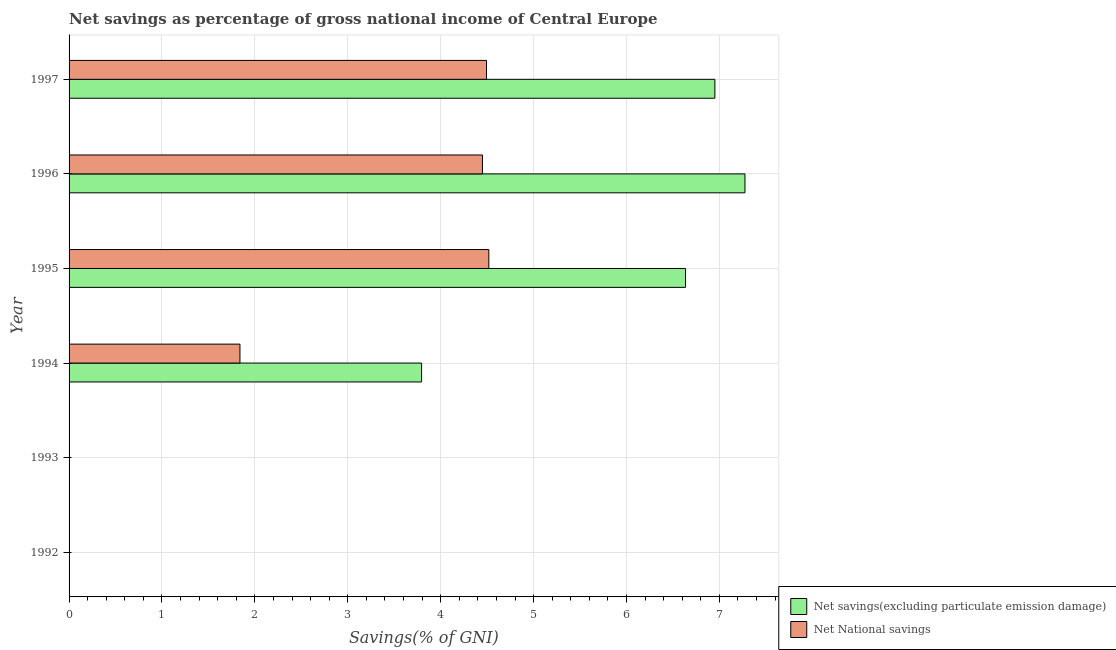How many different coloured bars are there?
Your response must be concise. 2. Are the number of bars on each tick of the Y-axis equal?
Provide a succinct answer. No. What is the label of the 5th group of bars from the top?
Provide a succinct answer. 1993. What is the net savings(excluding particulate emission damage) in 1993?
Ensure brevity in your answer.  0. Across all years, what is the maximum net national savings?
Provide a succinct answer. 4.52. Across all years, what is the minimum net national savings?
Provide a short and direct response. 0. What is the total net savings(excluding particulate emission damage) in the graph?
Offer a very short reply. 24.66. What is the difference between the net savings(excluding particulate emission damage) in 1994 and that in 1996?
Offer a terse response. -3.48. What is the difference between the net savings(excluding particulate emission damage) in 1997 and the net national savings in 1995?
Ensure brevity in your answer.  2.43. What is the average net national savings per year?
Give a very brief answer. 2.55. In the year 1995, what is the difference between the net savings(excluding particulate emission damage) and net national savings?
Offer a terse response. 2.12. In how many years, is the net national savings greater than 3.6 %?
Offer a very short reply. 3. What is the ratio of the net savings(excluding particulate emission damage) in 1995 to that in 1997?
Your answer should be very brief. 0.95. Is the net savings(excluding particulate emission damage) in 1996 less than that in 1997?
Ensure brevity in your answer.  No. Is the difference between the net savings(excluding particulate emission damage) in 1995 and 1997 greater than the difference between the net national savings in 1995 and 1997?
Give a very brief answer. No. What is the difference between the highest and the second highest net national savings?
Ensure brevity in your answer.  0.03. What is the difference between the highest and the lowest net savings(excluding particulate emission damage)?
Make the answer very short. 7.28. In how many years, is the net national savings greater than the average net national savings taken over all years?
Your answer should be very brief. 3. How many bars are there?
Your answer should be very brief. 8. Does the graph contain any zero values?
Keep it short and to the point. Yes. What is the title of the graph?
Provide a short and direct response. Net savings as percentage of gross national income of Central Europe. What is the label or title of the X-axis?
Make the answer very short. Savings(% of GNI). What is the label or title of the Y-axis?
Give a very brief answer. Year. What is the Savings(% of GNI) in Net savings(excluding particulate emission damage) in 1992?
Offer a very short reply. 0. What is the Savings(% of GNI) of Net savings(excluding particulate emission damage) in 1993?
Make the answer very short. 0. What is the Savings(% of GNI) of Net savings(excluding particulate emission damage) in 1994?
Your answer should be compact. 3.79. What is the Savings(% of GNI) of Net National savings in 1994?
Your response must be concise. 1.84. What is the Savings(% of GNI) in Net savings(excluding particulate emission damage) in 1995?
Your answer should be very brief. 6.64. What is the Savings(% of GNI) in Net National savings in 1995?
Your answer should be compact. 4.52. What is the Savings(% of GNI) of Net savings(excluding particulate emission damage) in 1996?
Provide a succinct answer. 7.28. What is the Savings(% of GNI) in Net National savings in 1996?
Provide a succinct answer. 4.45. What is the Savings(% of GNI) in Net savings(excluding particulate emission damage) in 1997?
Keep it short and to the point. 6.95. What is the Savings(% of GNI) in Net National savings in 1997?
Make the answer very short. 4.49. Across all years, what is the maximum Savings(% of GNI) in Net savings(excluding particulate emission damage)?
Make the answer very short. 7.28. Across all years, what is the maximum Savings(% of GNI) in Net National savings?
Provide a succinct answer. 4.52. Across all years, what is the minimum Savings(% of GNI) of Net savings(excluding particulate emission damage)?
Your answer should be very brief. 0. Across all years, what is the minimum Savings(% of GNI) of Net National savings?
Keep it short and to the point. 0. What is the total Savings(% of GNI) in Net savings(excluding particulate emission damage) in the graph?
Make the answer very short. 24.66. What is the total Savings(% of GNI) of Net National savings in the graph?
Your answer should be very brief. 15.3. What is the difference between the Savings(% of GNI) in Net savings(excluding particulate emission damage) in 1994 and that in 1995?
Offer a terse response. -2.84. What is the difference between the Savings(% of GNI) in Net National savings in 1994 and that in 1995?
Ensure brevity in your answer.  -2.68. What is the difference between the Savings(% of GNI) of Net savings(excluding particulate emission damage) in 1994 and that in 1996?
Your response must be concise. -3.48. What is the difference between the Savings(% of GNI) of Net National savings in 1994 and that in 1996?
Your answer should be compact. -2.61. What is the difference between the Savings(% of GNI) of Net savings(excluding particulate emission damage) in 1994 and that in 1997?
Your answer should be compact. -3.16. What is the difference between the Savings(% of GNI) of Net National savings in 1994 and that in 1997?
Provide a succinct answer. -2.65. What is the difference between the Savings(% of GNI) of Net savings(excluding particulate emission damage) in 1995 and that in 1996?
Ensure brevity in your answer.  -0.64. What is the difference between the Savings(% of GNI) in Net National savings in 1995 and that in 1996?
Ensure brevity in your answer.  0.07. What is the difference between the Savings(% of GNI) in Net savings(excluding particulate emission damage) in 1995 and that in 1997?
Offer a terse response. -0.32. What is the difference between the Savings(% of GNI) in Net National savings in 1995 and that in 1997?
Your response must be concise. 0.03. What is the difference between the Savings(% of GNI) in Net savings(excluding particulate emission damage) in 1996 and that in 1997?
Your answer should be very brief. 0.32. What is the difference between the Savings(% of GNI) of Net National savings in 1996 and that in 1997?
Give a very brief answer. -0.04. What is the difference between the Savings(% of GNI) in Net savings(excluding particulate emission damage) in 1994 and the Savings(% of GNI) in Net National savings in 1995?
Make the answer very short. -0.72. What is the difference between the Savings(% of GNI) in Net savings(excluding particulate emission damage) in 1994 and the Savings(% of GNI) in Net National savings in 1996?
Provide a short and direct response. -0.66. What is the difference between the Savings(% of GNI) in Net savings(excluding particulate emission damage) in 1994 and the Savings(% of GNI) in Net National savings in 1997?
Provide a short and direct response. -0.7. What is the difference between the Savings(% of GNI) of Net savings(excluding particulate emission damage) in 1995 and the Savings(% of GNI) of Net National savings in 1996?
Make the answer very short. 2.19. What is the difference between the Savings(% of GNI) in Net savings(excluding particulate emission damage) in 1995 and the Savings(% of GNI) in Net National savings in 1997?
Provide a succinct answer. 2.14. What is the difference between the Savings(% of GNI) in Net savings(excluding particulate emission damage) in 1996 and the Savings(% of GNI) in Net National savings in 1997?
Your answer should be very brief. 2.78. What is the average Savings(% of GNI) of Net savings(excluding particulate emission damage) per year?
Provide a short and direct response. 4.11. What is the average Savings(% of GNI) in Net National savings per year?
Make the answer very short. 2.55. In the year 1994, what is the difference between the Savings(% of GNI) of Net savings(excluding particulate emission damage) and Savings(% of GNI) of Net National savings?
Your answer should be compact. 1.96. In the year 1995, what is the difference between the Savings(% of GNI) in Net savings(excluding particulate emission damage) and Savings(% of GNI) in Net National savings?
Make the answer very short. 2.12. In the year 1996, what is the difference between the Savings(% of GNI) of Net savings(excluding particulate emission damage) and Savings(% of GNI) of Net National savings?
Your answer should be very brief. 2.83. In the year 1997, what is the difference between the Savings(% of GNI) in Net savings(excluding particulate emission damage) and Savings(% of GNI) in Net National savings?
Your answer should be very brief. 2.46. What is the ratio of the Savings(% of GNI) in Net savings(excluding particulate emission damage) in 1994 to that in 1995?
Your response must be concise. 0.57. What is the ratio of the Savings(% of GNI) of Net National savings in 1994 to that in 1995?
Your response must be concise. 0.41. What is the ratio of the Savings(% of GNI) of Net savings(excluding particulate emission damage) in 1994 to that in 1996?
Your response must be concise. 0.52. What is the ratio of the Savings(% of GNI) of Net National savings in 1994 to that in 1996?
Provide a short and direct response. 0.41. What is the ratio of the Savings(% of GNI) of Net savings(excluding particulate emission damage) in 1994 to that in 1997?
Your answer should be very brief. 0.55. What is the ratio of the Savings(% of GNI) in Net National savings in 1994 to that in 1997?
Provide a short and direct response. 0.41. What is the ratio of the Savings(% of GNI) in Net savings(excluding particulate emission damage) in 1995 to that in 1996?
Your response must be concise. 0.91. What is the ratio of the Savings(% of GNI) of Net National savings in 1995 to that in 1996?
Ensure brevity in your answer.  1.02. What is the ratio of the Savings(% of GNI) in Net savings(excluding particulate emission damage) in 1995 to that in 1997?
Make the answer very short. 0.95. What is the ratio of the Savings(% of GNI) of Net National savings in 1995 to that in 1997?
Ensure brevity in your answer.  1.01. What is the ratio of the Savings(% of GNI) in Net savings(excluding particulate emission damage) in 1996 to that in 1997?
Make the answer very short. 1.05. What is the ratio of the Savings(% of GNI) of Net National savings in 1996 to that in 1997?
Provide a succinct answer. 0.99. What is the difference between the highest and the second highest Savings(% of GNI) of Net savings(excluding particulate emission damage)?
Keep it short and to the point. 0.32. What is the difference between the highest and the second highest Savings(% of GNI) in Net National savings?
Give a very brief answer. 0.03. What is the difference between the highest and the lowest Savings(% of GNI) of Net savings(excluding particulate emission damage)?
Provide a short and direct response. 7.28. What is the difference between the highest and the lowest Savings(% of GNI) of Net National savings?
Your answer should be compact. 4.52. 